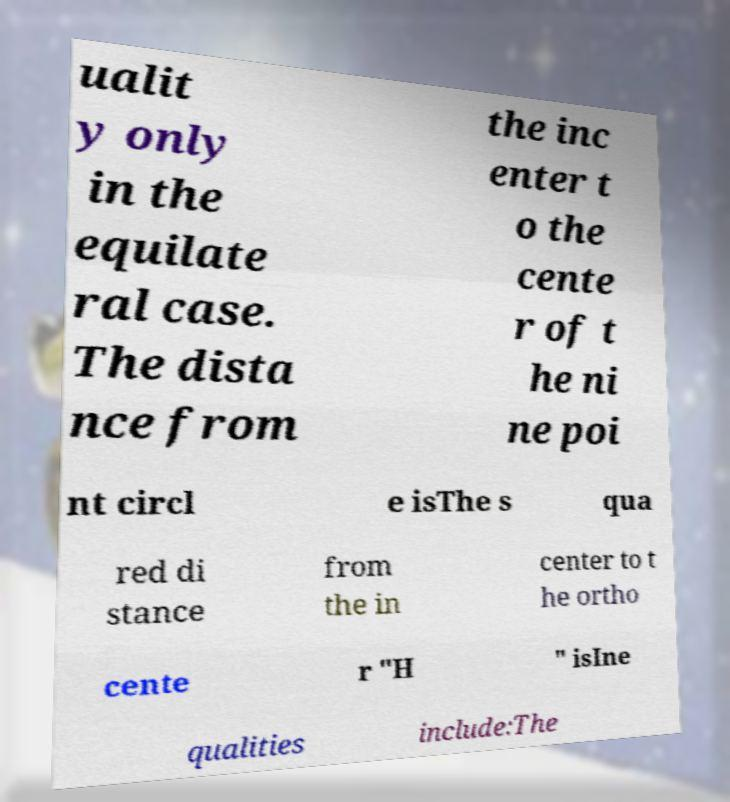For documentation purposes, I need the text within this image transcribed. Could you provide that? ualit y only in the equilate ral case. The dista nce from the inc enter t o the cente r of t he ni ne poi nt circl e isThe s qua red di stance from the in center to t he ortho cente r "H " isIne qualities include:The 